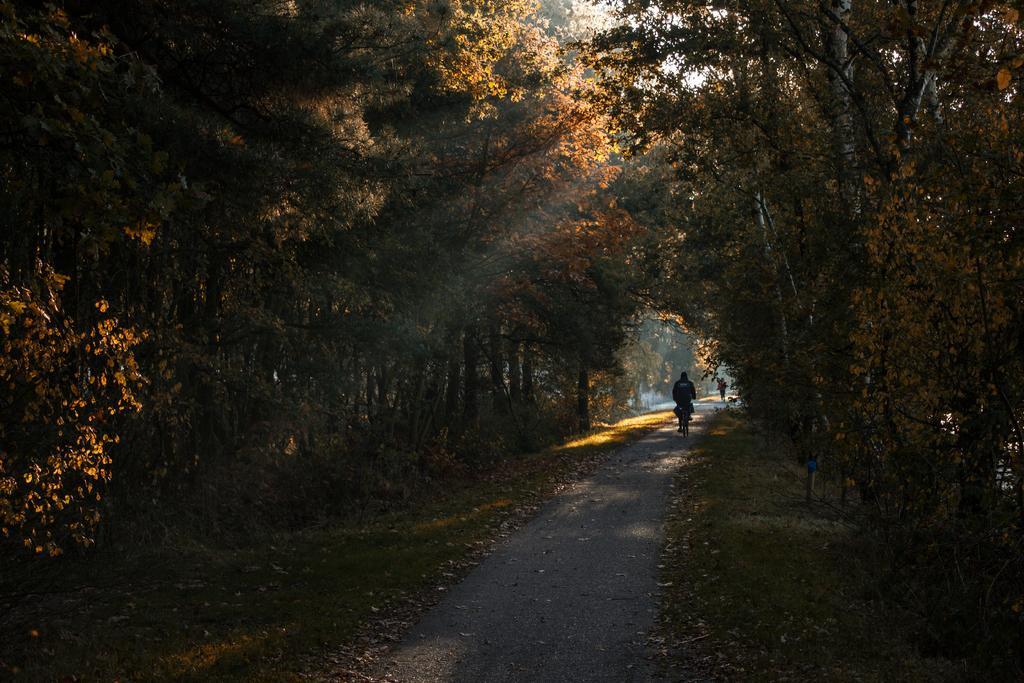Please provide a concise description of this image. In this image, we can see a road in between trees. There is a person in the middle of the image riding a bicycle. 